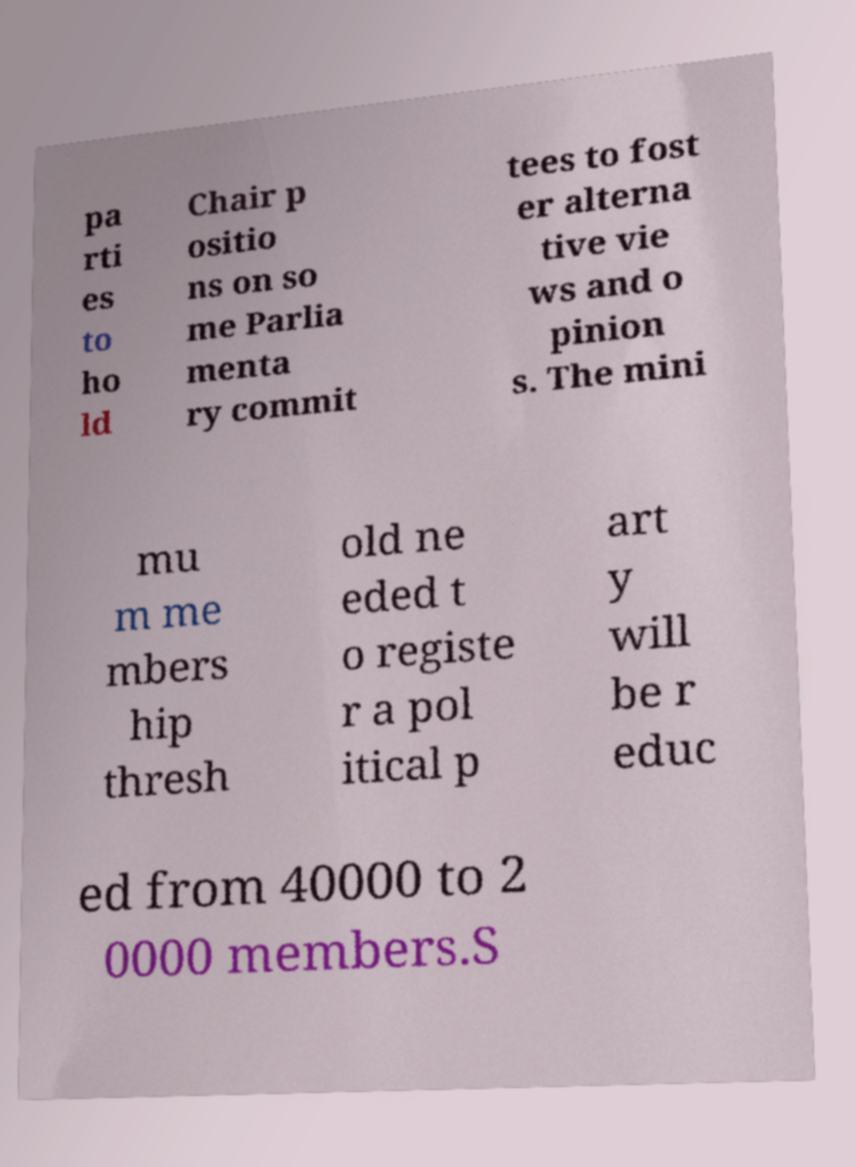I need the written content from this picture converted into text. Can you do that? pa rti es to ho ld Chair p ositio ns on so me Parlia menta ry commit tees to fost er alterna tive vie ws and o pinion s. The mini mu m me mbers hip thresh old ne eded t o registe r a pol itical p art y will be r educ ed from 40000 to 2 0000 members.S 